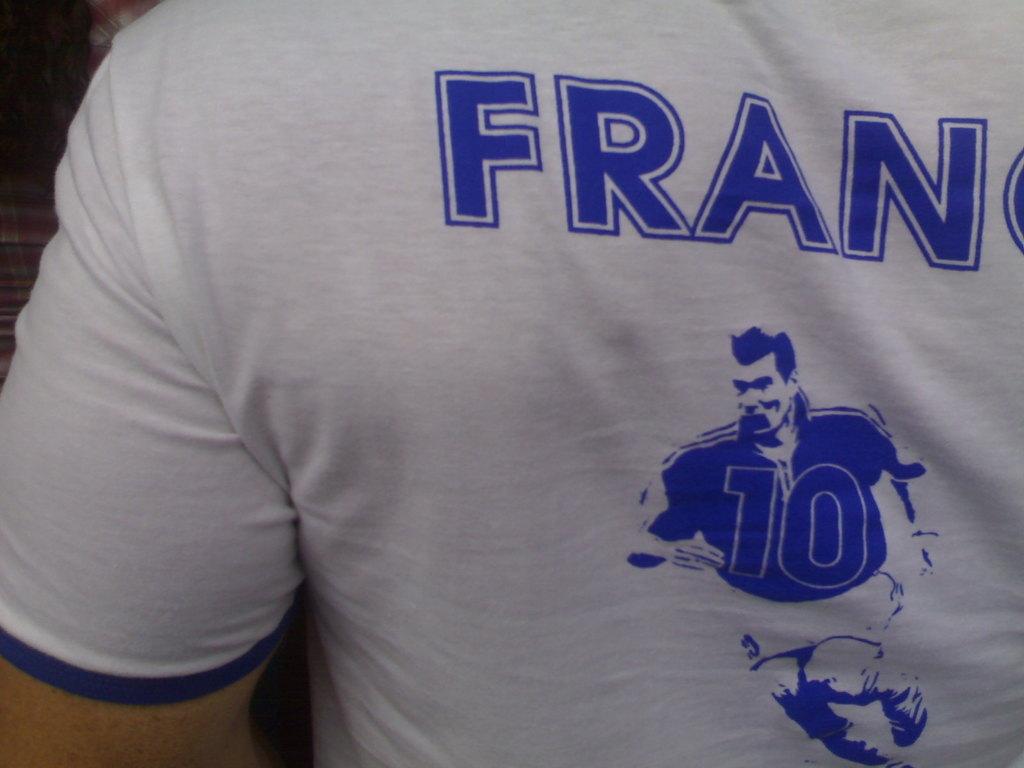What number is on the jersey?
Keep it short and to the point. 10. 